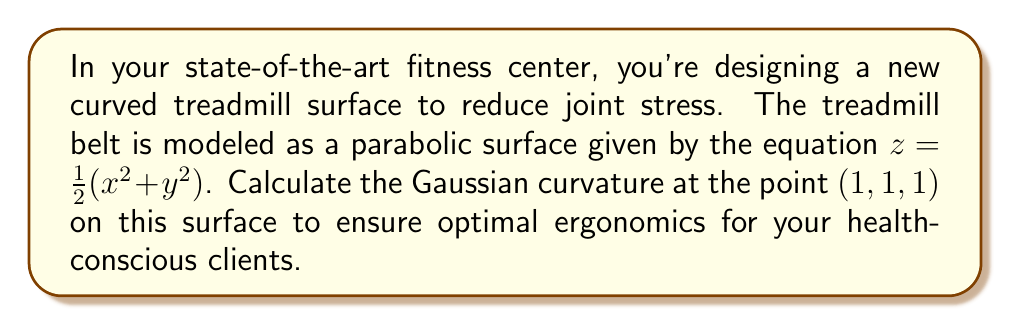Solve this math problem. To calculate the Gaussian curvature of the surface, we'll follow these steps:

1) First, we need to find the partial derivatives:
   $f_x = x$, $f_y = y$, $f_{xx} = 1$, $f_{yy} = 1$, $f_{xy} = 0$

2) The Gaussian curvature K is given by the formula:
   $$K = \frac{f_{xx}f_{yy} - f_{xy}^2}{(1 + f_x^2 + f_y^2)^2}$$

3) At the point (1, 1, 1), we have:
   $f_x = 1$, $f_y = 1$, $f_{xx} = 1$, $f_{yy} = 1$, $f_{xy} = 0$

4) Substituting these values into the formula:
   $$K = \frac{(1)(1) - (0)^2}{(1 + 1^2 + 1^2)^2} = \frac{1}{(1 + 1 + 1)^2} = \frac{1}{9}$$

5) Therefore, the Gaussian curvature at the point (1, 1, 1) is $\frac{1}{9}$.

This positive curvature indicates that the surface is dome-shaped at this point, which can help distribute the user's weight and reduce joint stress during exercise.
Answer: $\frac{1}{9}$ 